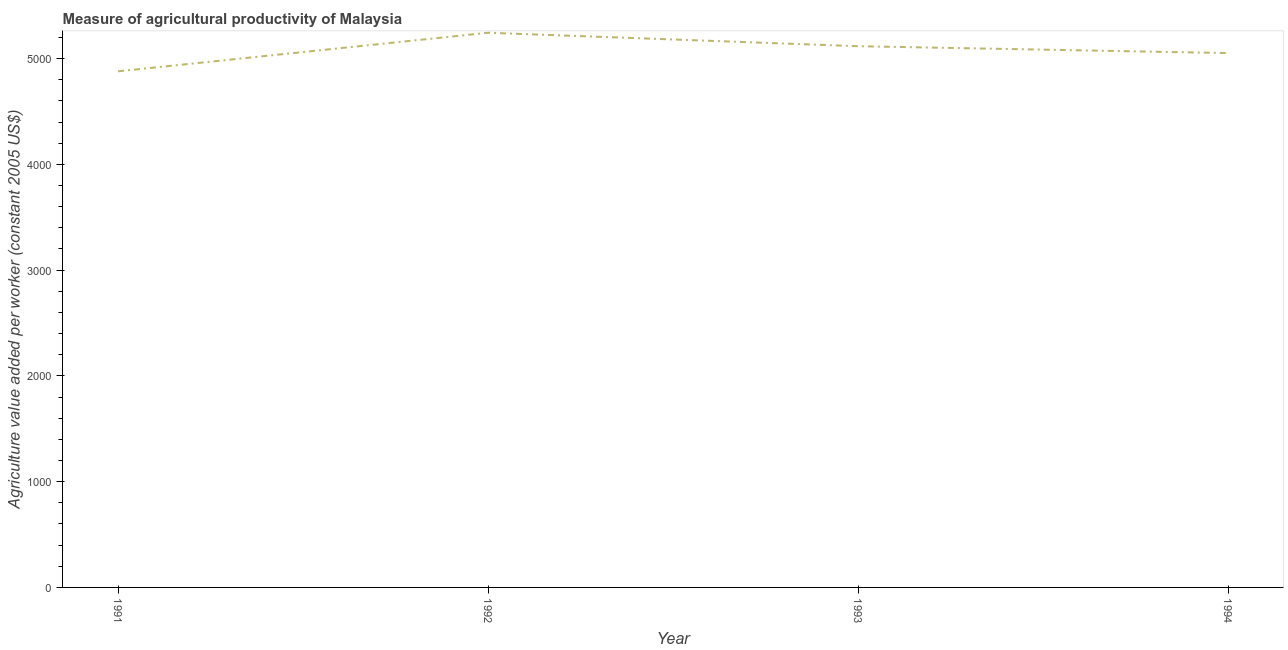What is the agriculture value added per worker in 1994?
Offer a very short reply. 5051.82. Across all years, what is the maximum agriculture value added per worker?
Give a very brief answer. 5244.05. Across all years, what is the minimum agriculture value added per worker?
Offer a terse response. 4879.43. In which year was the agriculture value added per worker maximum?
Provide a short and direct response. 1992. What is the sum of the agriculture value added per worker?
Your response must be concise. 2.03e+04. What is the difference between the agriculture value added per worker in 1993 and 1994?
Offer a terse response. 65.03. What is the average agriculture value added per worker per year?
Provide a short and direct response. 5073.04. What is the median agriculture value added per worker?
Provide a succinct answer. 5084.34. What is the ratio of the agriculture value added per worker in 1992 to that in 1994?
Keep it short and to the point. 1.04. Is the agriculture value added per worker in 1991 less than that in 1994?
Offer a terse response. Yes. What is the difference between the highest and the second highest agriculture value added per worker?
Make the answer very short. 127.2. Is the sum of the agriculture value added per worker in 1991 and 1992 greater than the maximum agriculture value added per worker across all years?
Make the answer very short. Yes. What is the difference between the highest and the lowest agriculture value added per worker?
Offer a very short reply. 364.61. In how many years, is the agriculture value added per worker greater than the average agriculture value added per worker taken over all years?
Your answer should be compact. 2. How many lines are there?
Your answer should be very brief. 1. How many years are there in the graph?
Offer a very short reply. 4. What is the difference between two consecutive major ticks on the Y-axis?
Keep it short and to the point. 1000. Are the values on the major ticks of Y-axis written in scientific E-notation?
Ensure brevity in your answer.  No. Does the graph contain grids?
Offer a terse response. No. What is the title of the graph?
Offer a terse response. Measure of agricultural productivity of Malaysia. What is the label or title of the X-axis?
Ensure brevity in your answer.  Year. What is the label or title of the Y-axis?
Make the answer very short. Agriculture value added per worker (constant 2005 US$). What is the Agriculture value added per worker (constant 2005 US$) of 1991?
Give a very brief answer. 4879.43. What is the Agriculture value added per worker (constant 2005 US$) of 1992?
Offer a terse response. 5244.05. What is the Agriculture value added per worker (constant 2005 US$) in 1993?
Your answer should be very brief. 5116.85. What is the Agriculture value added per worker (constant 2005 US$) in 1994?
Give a very brief answer. 5051.82. What is the difference between the Agriculture value added per worker (constant 2005 US$) in 1991 and 1992?
Give a very brief answer. -364.61. What is the difference between the Agriculture value added per worker (constant 2005 US$) in 1991 and 1993?
Your answer should be very brief. -237.42. What is the difference between the Agriculture value added per worker (constant 2005 US$) in 1991 and 1994?
Offer a very short reply. -172.39. What is the difference between the Agriculture value added per worker (constant 2005 US$) in 1992 and 1993?
Offer a terse response. 127.2. What is the difference between the Agriculture value added per worker (constant 2005 US$) in 1992 and 1994?
Ensure brevity in your answer.  192.22. What is the difference between the Agriculture value added per worker (constant 2005 US$) in 1993 and 1994?
Your answer should be compact. 65.03. What is the ratio of the Agriculture value added per worker (constant 2005 US$) in 1991 to that in 1993?
Offer a very short reply. 0.95. What is the ratio of the Agriculture value added per worker (constant 2005 US$) in 1991 to that in 1994?
Your answer should be compact. 0.97. What is the ratio of the Agriculture value added per worker (constant 2005 US$) in 1992 to that in 1993?
Ensure brevity in your answer.  1.02. What is the ratio of the Agriculture value added per worker (constant 2005 US$) in 1992 to that in 1994?
Keep it short and to the point. 1.04. What is the ratio of the Agriculture value added per worker (constant 2005 US$) in 1993 to that in 1994?
Make the answer very short. 1.01. 